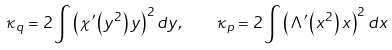<formula> <loc_0><loc_0><loc_500><loc_500>\kappa _ { q } = 2 \int \left ( \chi ^ { \prime } \left ( y ^ { 2 } \right ) y \right ) ^ { 2 } d y , \quad \kappa _ { p } = 2 \int \left ( \Lambda ^ { \prime } \left ( x ^ { 2 } \right ) x \right ) ^ { 2 } d x</formula> 